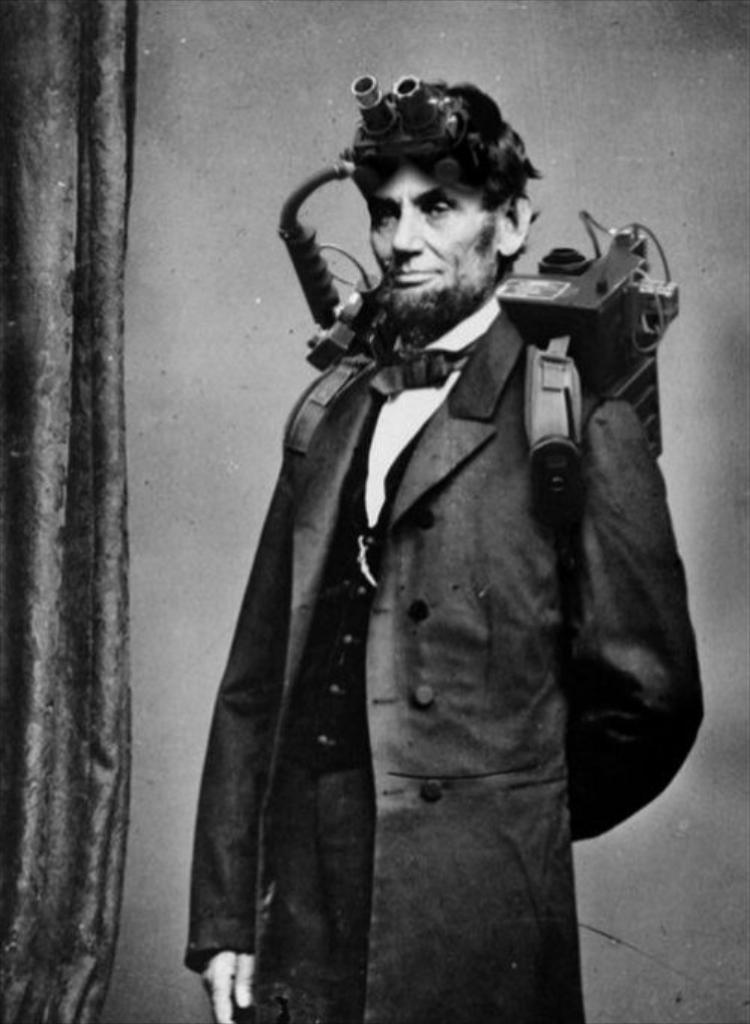Who is present in the image? There is a man in the image. What is the man wearing? The man is wearing a coat. What object can be seen in the image related to safety or protection? There is a mask in the image. What can be seen in the background of the image? There is a wall in the background of the image. What type of bead is being used to control the speed of the man in the image? There is no bead present in the image, nor is there any indication that the man's speed needs to be controlled. 